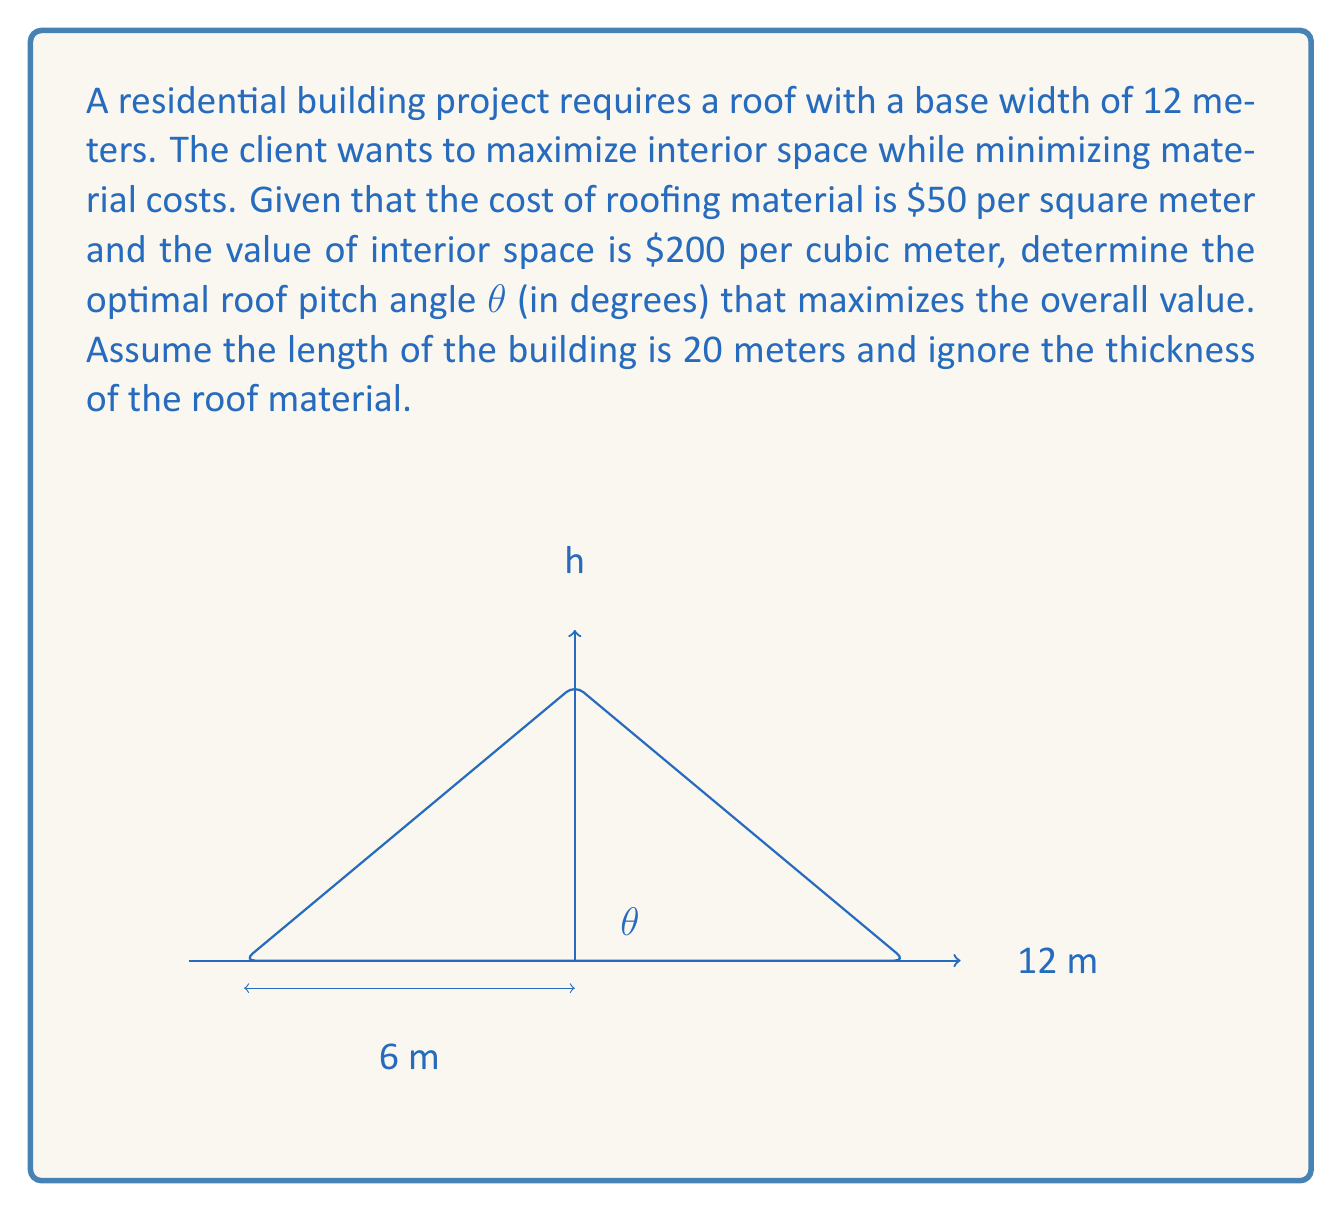Teach me how to tackle this problem. Let's approach this problem step by step:

1) First, we need to express the roof area and interior volume in terms of the angle $\theta$.

2) The roof area $A$ is given by:
   $$A = \frac{12}{\cos\theta} \cdot 20 = \frac{240}{\cos\theta}$$

3) The interior volume $V$ is the area of the triangle multiplied by the length:
   $$V = \frac{1}{2} \cdot 12 \cdot (6\tan\theta) \cdot 20 = 720\tan\theta$$

4) The cost of the roof is:
   $$C_r = 50A = \frac{12000}{\cos\theta}$$

5) The value of the interior space is:
   $$V_i = 200V = 144000\tan\theta$$

6) The net value $N$ is the difference between the interior value and the roof cost:
   $$N = 144000\tan\theta - \frac{12000}{\cos\theta}$$

7) To find the maximum value, we differentiate $N$ with respect to $\theta$ and set it to zero:
   $$\frac{dN}{d\theta} = 144000\sec^2\theta - 12000\sin\theta\cos^{-2}\theta = 0$$

8) Simplifying:
   $$144000\sec^2\theta = 12000\sin\theta\cos^{-2}\theta$$
   $$144000 = 12000\sin\theta\cos\theta$$
   $$12 = \sin\theta\cos\theta = \frac{1}{2}\sin(2\theta)$$

9) Solving for $\theta$:
   $$\sin(2\theta) = 24$$
   $$2\theta = \arcsin(24) = 66.44^\circ$$
   $$\theta = 33.22^\circ$$

10) To confirm this is a maximum, we can check the second derivative is negative at this point.
Answer: The optimal roof pitch angle is approximately $33.22^\circ$. 